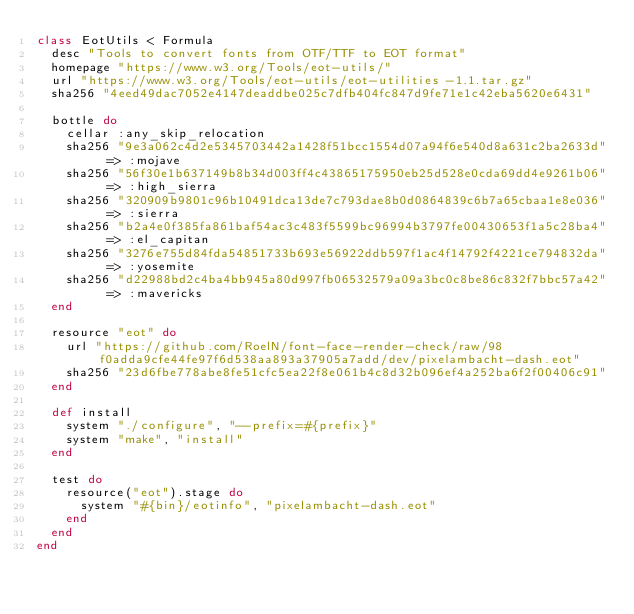Convert code to text. <code><loc_0><loc_0><loc_500><loc_500><_Ruby_>class EotUtils < Formula
  desc "Tools to convert fonts from OTF/TTF to EOT format"
  homepage "https://www.w3.org/Tools/eot-utils/"
  url "https://www.w3.org/Tools/eot-utils/eot-utilities-1.1.tar.gz"
  sha256 "4eed49dac7052e4147deaddbe025c7dfb404fc847d9fe71e1c42eba5620e6431"

  bottle do
    cellar :any_skip_relocation
    sha256 "9e3a062c4d2e5345703442a1428f51bcc1554d07a94f6e540d8a631c2ba2633d" => :mojave
    sha256 "56f30e1b637149b8b34d003ff4c43865175950eb25d528e0cda69dd4e9261b06" => :high_sierra
    sha256 "320909b9801c96b10491dca13de7c793dae8b0d0864839c6b7a65cbaa1e8e036" => :sierra
    sha256 "b2a4e0f385fa861baf54ac3c483f5599bc96994b3797fe00430653f1a5c28ba4" => :el_capitan
    sha256 "3276e755d84fda54851733b693e56922ddb597f1ac4f14792f4221ce794832da" => :yosemite
    sha256 "d22988bd2c4ba4bb945a80d997fb06532579a09a3bc0c8be86c832f7bbc57a42" => :mavericks
  end

  resource "eot" do
    url "https://github.com/RoelN/font-face-render-check/raw/98f0adda9cfe44fe97f6d538aa893a37905a7add/dev/pixelambacht-dash.eot"
    sha256 "23d6fbe778abe8fe51cfc5ea22f8e061b4c8d32b096ef4a252ba6f2f00406c91"
  end

  def install
    system "./configure", "--prefix=#{prefix}"
    system "make", "install"
  end

  test do
    resource("eot").stage do
      system "#{bin}/eotinfo", "pixelambacht-dash.eot"
    end
  end
end
</code> 